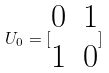Convert formula to latex. <formula><loc_0><loc_0><loc_500><loc_500>U _ { 0 } = [ \begin{matrix} 0 & 1 \\ 1 & 0 \end{matrix} ]</formula> 